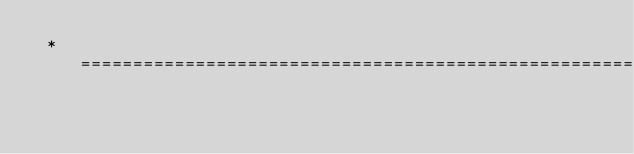<code> <loc_0><loc_0><loc_500><loc_500><_CSS_> * =============================================================</code> 